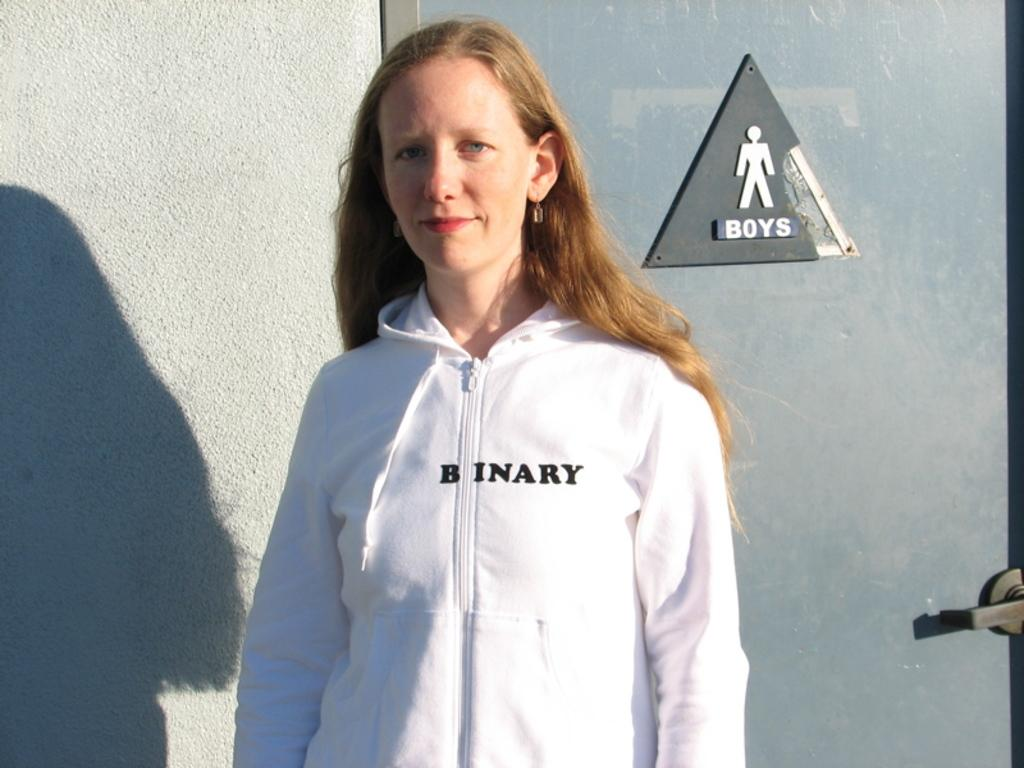Provide a one-sentence caption for the provided image. A woman in a "binary" sweatshirt stands in front of a boys bathroom. 